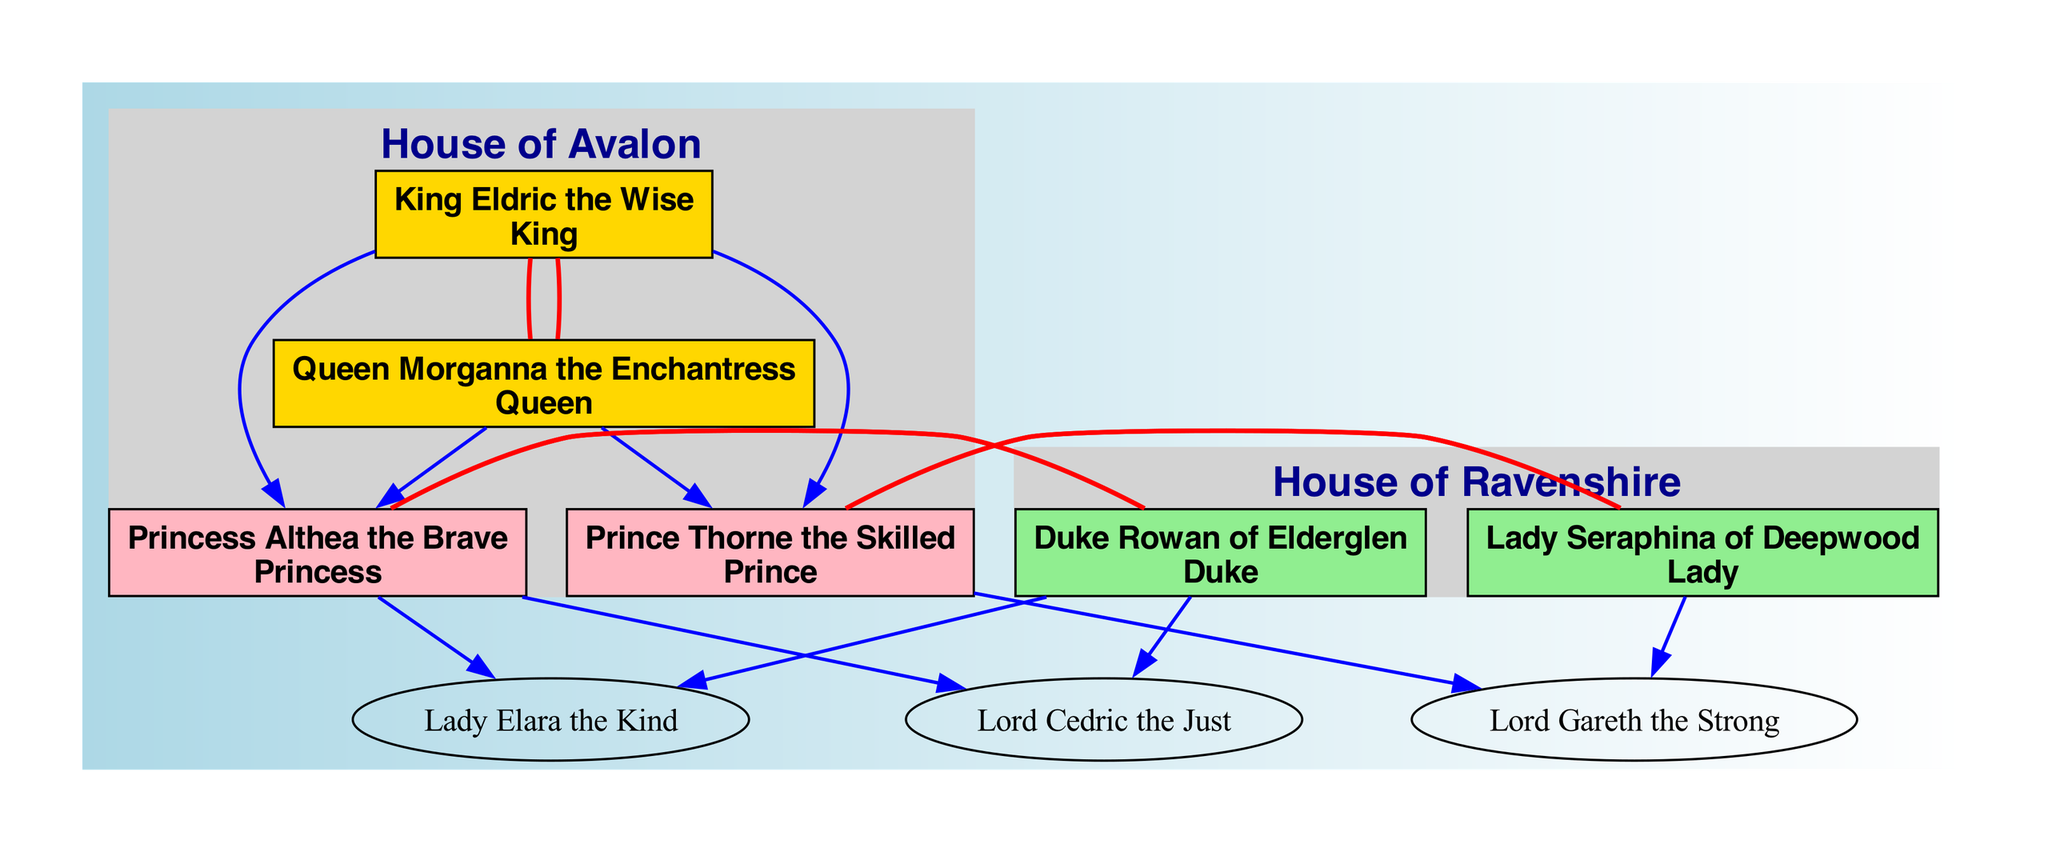What is the title of King Eldric? The diagram identifies King Eldric as "King," which is located at the top of the House of Avalon section.
Answer: King How many children do King Eldric and Queen Morganna have? The diagram lists two children under King Eldric and Queen Morganna: Princess Althea the Brave and Prince Thorne the Skilled, which indicates they have a total of two children.
Answer: 2 Who is the spouse of Princess Althea? The diagram shows that Princess Althea is married to Duke Rowan of Elderglen, which is clearly indicated by the connecting edge between them in the diagram.
Answer: Duke Rowan of Elderglen Which title does Lord Gareth hold? Based on the diagram, Lord Gareth is identified as "Lord," and this is specified under his name in the House of Avalon section, making this association clear.
Answer: Lord What is the relationship between Prince Thorne and Lady Seraphina? The diagram indicates Princess Thorne is married to Lady Seraphina of Deepwood, as shown by the connecting edge without a direction, which means they are spouses.
Answer: Spouses Which two houses are represented in the family tree? The diagram features two distinct royal families: the House of Avalon and the House of Ravenshire, both of which are outlined in their subgraphs.
Answer: House of Avalon and House of Ravenshire How many members are in the House of Ravenshire? Upon inspection of the members listed in the House of Ravenshire, there are three members: Duke Rowan, Lady Seraphina, and their child Lord Gareth, totaling three members.
Answer: 3 Who are the children of Princess Althea? The diagram states that the children of Princess Althea are Lady Elara the Kind and Lord Cedric the Just, which is clearly noted under her name in the family tree.
Answer: Lady Elara the Kind and Lord Cedric the Just Who is the eldest child of King Eldric? The diagram names Princess Althea the Brave as the first child under King Eldric and Queen Morganna, making her the eldest child in the family tree.
Answer: Princess Althea the Brave 